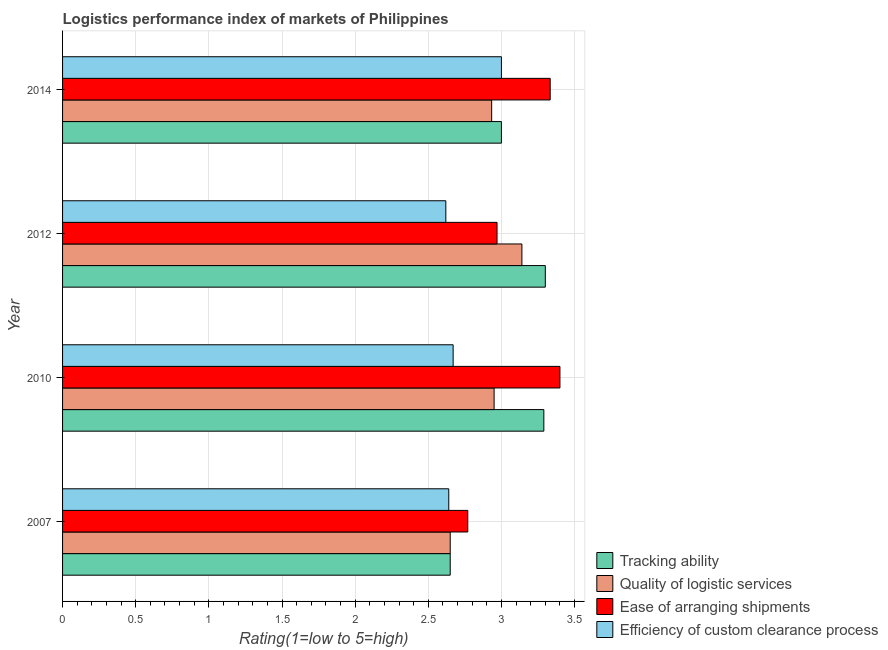How many different coloured bars are there?
Offer a terse response. 4. How many bars are there on the 3rd tick from the top?
Give a very brief answer. 4. What is the label of the 4th group of bars from the top?
Make the answer very short. 2007. What is the lpi rating of quality of logistic services in 2012?
Provide a short and direct response. 3.14. Across all years, what is the maximum lpi rating of efficiency of custom clearance process?
Give a very brief answer. 3. Across all years, what is the minimum lpi rating of efficiency of custom clearance process?
Make the answer very short. 2.62. In which year was the lpi rating of ease of arranging shipments maximum?
Keep it short and to the point. 2010. What is the total lpi rating of ease of arranging shipments in the graph?
Provide a succinct answer. 12.47. What is the difference between the lpi rating of tracking ability in 2010 and that in 2014?
Your answer should be very brief. 0.29. What is the difference between the lpi rating of tracking ability in 2012 and the lpi rating of efficiency of custom clearance process in 2007?
Your answer should be very brief. 0.66. What is the average lpi rating of quality of logistic services per year?
Make the answer very short. 2.92. In the year 2007, what is the difference between the lpi rating of quality of logistic services and lpi rating of ease of arranging shipments?
Offer a very short reply. -0.12. In how many years, is the lpi rating of tracking ability greater than 2 ?
Your answer should be compact. 4. What is the ratio of the lpi rating of tracking ability in 2007 to that in 2010?
Your answer should be very brief. 0.81. Is the lpi rating of efficiency of custom clearance process in 2007 less than that in 2014?
Offer a very short reply. Yes. Is the difference between the lpi rating of tracking ability in 2010 and 2012 greater than the difference between the lpi rating of efficiency of custom clearance process in 2010 and 2012?
Provide a succinct answer. No. What is the difference between the highest and the second highest lpi rating of quality of logistic services?
Provide a succinct answer. 0.19. What is the difference between the highest and the lowest lpi rating of quality of logistic services?
Make the answer very short. 0.49. In how many years, is the lpi rating of ease of arranging shipments greater than the average lpi rating of ease of arranging shipments taken over all years?
Ensure brevity in your answer.  2. Is the sum of the lpi rating of tracking ability in 2007 and 2014 greater than the maximum lpi rating of quality of logistic services across all years?
Make the answer very short. Yes. What does the 1st bar from the top in 2010 represents?
Provide a succinct answer. Efficiency of custom clearance process. What does the 4th bar from the bottom in 2007 represents?
Your answer should be very brief. Efficiency of custom clearance process. How many bars are there?
Your response must be concise. 16. What is the difference between two consecutive major ticks on the X-axis?
Ensure brevity in your answer.  0.5. Are the values on the major ticks of X-axis written in scientific E-notation?
Your answer should be compact. No. Does the graph contain any zero values?
Your answer should be compact. No. How are the legend labels stacked?
Give a very brief answer. Vertical. What is the title of the graph?
Your answer should be very brief. Logistics performance index of markets of Philippines. Does "Industry" appear as one of the legend labels in the graph?
Make the answer very short. No. What is the label or title of the X-axis?
Provide a succinct answer. Rating(1=low to 5=high). What is the label or title of the Y-axis?
Your response must be concise. Year. What is the Rating(1=low to 5=high) of Tracking ability in 2007?
Ensure brevity in your answer.  2.65. What is the Rating(1=low to 5=high) of Quality of logistic services in 2007?
Provide a succinct answer. 2.65. What is the Rating(1=low to 5=high) of Ease of arranging shipments in 2007?
Offer a very short reply. 2.77. What is the Rating(1=low to 5=high) in Efficiency of custom clearance process in 2007?
Your answer should be very brief. 2.64. What is the Rating(1=low to 5=high) in Tracking ability in 2010?
Your response must be concise. 3.29. What is the Rating(1=low to 5=high) in Quality of logistic services in 2010?
Offer a very short reply. 2.95. What is the Rating(1=low to 5=high) in Ease of arranging shipments in 2010?
Your answer should be compact. 3.4. What is the Rating(1=low to 5=high) of Efficiency of custom clearance process in 2010?
Ensure brevity in your answer.  2.67. What is the Rating(1=low to 5=high) of Tracking ability in 2012?
Make the answer very short. 3.3. What is the Rating(1=low to 5=high) in Quality of logistic services in 2012?
Make the answer very short. 3.14. What is the Rating(1=low to 5=high) in Ease of arranging shipments in 2012?
Your answer should be very brief. 2.97. What is the Rating(1=low to 5=high) in Efficiency of custom clearance process in 2012?
Keep it short and to the point. 2.62. What is the Rating(1=low to 5=high) of Tracking ability in 2014?
Your response must be concise. 3. What is the Rating(1=low to 5=high) in Quality of logistic services in 2014?
Your answer should be very brief. 2.93. What is the Rating(1=low to 5=high) in Ease of arranging shipments in 2014?
Your answer should be compact. 3.33. Across all years, what is the maximum Rating(1=low to 5=high) of Quality of logistic services?
Your response must be concise. 3.14. Across all years, what is the maximum Rating(1=low to 5=high) in Ease of arranging shipments?
Give a very brief answer. 3.4. Across all years, what is the minimum Rating(1=low to 5=high) in Tracking ability?
Your answer should be very brief. 2.65. Across all years, what is the minimum Rating(1=low to 5=high) in Quality of logistic services?
Make the answer very short. 2.65. Across all years, what is the minimum Rating(1=low to 5=high) in Ease of arranging shipments?
Your response must be concise. 2.77. Across all years, what is the minimum Rating(1=low to 5=high) in Efficiency of custom clearance process?
Ensure brevity in your answer.  2.62. What is the total Rating(1=low to 5=high) of Tracking ability in the graph?
Your answer should be compact. 12.24. What is the total Rating(1=low to 5=high) of Quality of logistic services in the graph?
Provide a short and direct response. 11.67. What is the total Rating(1=low to 5=high) in Ease of arranging shipments in the graph?
Provide a short and direct response. 12.47. What is the total Rating(1=low to 5=high) in Efficiency of custom clearance process in the graph?
Keep it short and to the point. 10.93. What is the difference between the Rating(1=low to 5=high) in Tracking ability in 2007 and that in 2010?
Ensure brevity in your answer.  -0.64. What is the difference between the Rating(1=low to 5=high) in Ease of arranging shipments in 2007 and that in 2010?
Provide a short and direct response. -0.63. What is the difference between the Rating(1=low to 5=high) in Efficiency of custom clearance process in 2007 and that in 2010?
Make the answer very short. -0.03. What is the difference between the Rating(1=low to 5=high) of Tracking ability in 2007 and that in 2012?
Your answer should be compact. -0.65. What is the difference between the Rating(1=low to 5=high) in Quality of logistic services in 2007 and that in 2012?
Offer a very short reply. -0.49. What is the difference between the Rating(1=low to 5=high) of Ease of arranging shipments in 2007 and that in 2012?
Your answer should be very brief. -0.2. What is the difference between the Rating(1=low to 5=high) in Efficiency of custom clearance process in 2007 and that in 2012?
Your response must be concise. 0.02. What is the difference between the Rating(1=low to 5=high) of Tracking ability in 2007 and that in 2014?
Offer a very short reply. -0.35. What is the difference between the Rating(1=low to 5=high) of Quality of logistic services in 2007 and that in 2014?
Offer a terse response. -0.28. What is the difference between the Rating(1=low to 5=high) in Ease of arranging shipments in 2007 and that in 2014?
Your response must be concise. -0.56. What is the difference between the Rating(1=low to 5=high) in Efficiency of custom clearance process in 2007 and that in 2014?
Your answer should be compact. -0.36. What is the difference between the Rating(1=low to 5=high) in Tracking ability in 2010 and that in 2012?
Your response must be concise. -0.01. What is the difference between the Rating(1=low to 5=high) of Quality of logistic services in 2010 and that in 2012?
Provide a succinct answer. -0.19. What is the difference between the Rating(1=low to 5=high) in Ease of arranging shipments in 2010 and that in 2012?
Offer a very short reply. 0.43. What is the difference between the Rating(1=low to 5=high) of Efficiency of custom clearance process in 2010 and that in 2012?
Make the answer very short. 0.05. What is the difference between the Rating(1=low to 5=high) of Tracking ability in 2010 and that in 2014?
Make the answer very short. 0.29. What is the difference between the Rating(1=low to 5=high) in Quality of logistic services in 2010 and that in 2014?
Provide a succinct answer. 0.02. What is the difference between the Rating(1=low to 5=high) in Ease of arranging shipments in 2010 and that in 2014?
Provide a succinct answer. 0.07. What is the difference between the Rating(1=low to 5=high) of Efficiency of custom clearance process in 2010 and that in 2014?
Your response must be concise. -0.33. What is the difference between the Rating(1=low to 5=high) of Tracking ability in 2012 and that in 2014?
Provide a short and direct response. 0.3. What is the difference between the Rating(1=low to 5=high) in Quality of logistic services in 2012 and that in 2014?
Provide a short and direct response. 0.21. What is the difference between the Rating(1=low to 5=high) of Ease of arranging shipments in 2012 and that in 2014?
Keep it short and to the point. -0.36. What is the difference between the Rating(1=low to 5=high) in Efficiency of custom clearance process in 2012 and that in 2014?
Provide a short and direct response. -0.38. What is the difference between the Rating(1=low to 5=high) in Tracking ability in 2007 and the Rating(1=low to 5=high) in Quality of logistic services in 2010?
Provide a succinct answer. -0.3. What is the difference between the Rating(1=low to 5=high) in Tracking ability in 2007 and the Rating(1=low to 5=high) in Ease of arranging shipments in 2010?
Ensure brevity in your answer.  -0.75. What is the difference between the Rating(1=low to 5=high) of Tracking ability in 2007 and the Rating(1=low to 5=high) of Efficiency of custom clearance process in 2010?
Offer a terse response. -0.02. What is the difference between the Rating(1=low to 5=high) of Quality of logistic services in 2007 and the Rating(1=low to 5=high) of Ease of arranging shipments in 2010?
Provide a succinct answer. -0.75. What is the difference between the Rating(1=low to 5=high) of Quality of logistic services in 2007 and the Rating(1=low to 5=high) of Efficiency of custom clearance process in 2010?
Provide a succinct answer. -0.02. What is the difference between the Rating(1=low to 5=high) in Tracking ability in 2007 and the Rating(1=low to 5=high) in Quality of logistic services in 2012?
Your answer should be very brief. -0.49. What is the difference between the Rating(1=low to 5=high) of Tracking ability in 2007 and the Rating(1=low to 5=high) of Ease of arranging shipments in 2012?
Provide a short and direct response. -0.32. What is the difference between the Rating(1=low to 5=high) in Tracking ability in 2007 and the Rating(1=low to 5=high) in Efficiency of custom clearance process in 2012?
Your answer should be compact. 0.03. What is the difference between the Rating(1=low to 5=high) of Quality of logistic services in 2007 and the Rating(1=low to 5=high) of Ease of arranging shipments in 2012?
Give a very brief answer. -0.32. What is the difference between the Rating(1=low to 5=high) of Tracking ability in 2007 and the Rating(1=low to 5=high) of Quality of logistic services in 2014?
Offer a terse response. -0.28. What is the difference between the Rating(1=low to 5=high) in Tracking ability in 2007 and the Rating(1=low to 5=high) in Ease of arranging shipments in 2014?
Your answer should be very brief. -0.68. What is the difference between the Rating(1=low to 5=high) in Tracking ability in 2007 and the Rating(1=low to 5=high) in Efficiency of custom clearance process in 2014?
Make the answer very short. -0.35. What is the difference between the Rating(1=low to 5=high) in Quality of logistic services in 2007 and the Rating(1=low to 5=high) in Ease of arranging shipments in 2014?
Give a very brief answer. -0.68. What is the difference between the Rating(1=low to 5=high) in Quality of logistic services in 2007 and the Rating(1=low to 5=high) in Efficiency of custom clearance process in 2014?
Your answer should be compact. -0.35. What is the difference between the Rating(1=low to 5=high) in Ease of arranging shipments in 2007 and the Rating(1=low to 5=high) in Efficiency of custom clearance process in 2014?
Your answer should be compact. -0.23. What is the difference between the Rating(1=low to 5=high) in Tracking ability in 2010 and the Rating(1=low to 5=high) in Ease of arranging shipments in 2012?
Your response must be concise. 0.32. What is the difference between the Rating(1=low to 5=high) of Tracking ability in 2010 and the Rating(1=low to 5=high) of Efficiency of custom clearance process in 2012?
Provide a short and direct response. 0.67. What is the difference between the Rating(1=low to 5=high) in Quality of logistic services in 2010 and the Rating(1=low to 5=high) in Ease of arranging shipments in 2012?
Provide a succinct answer. -0.02. What is the difference between the Rating(1=low to 5=high) in Quality of logistic services in 2010 and the Rating(1=low to 5=high) in Efficiency of custom clearance process in 2012?
Provide a succinct answer. 0.33. What is the difference between the Rating(1=low to 5=high) in Ease of arranging shipments in 2010 and the Rating(1=low to 5=high) in Efficiency of custom clearance process in 2012?
Offer a terse response. 0.78. What is the difference between the Rating(1=low to 5=high) of Tracking ability in 2010 and the Rating(1=low to 5=high) of Quality of logistic services in 2014?
Your response must be concise. 0.36. What is the difference between the Rating(1=low to 5=high) of Tracking ability in 2010 and the Rating(1=low to 5=high) of Ease of arranging shipments in 2014?
Keep it short and to the point. -0.04. What is the difference between the Rating(1=low to 5=high) of Tracking ability in 2010 and the Rating(1=low to 5=high) of Efficiency of custom clearance process in 2014?
Your answer should be very brief. 0.29. What is the difference between the Rating(1=low to 5=high) in Quality of logistic services in 2010 and the Rating(1=low to 5=high) in Ease of arranging shipments in 2014?
Give a very brief answer. -0.38. What is the difference between the Rating(1=low to 5=high) of Quality of logistic services in 2010 and the Rating(1=low to 5=high) of Efficiency of custom clearance process in 2014?
Offer a terse response. -0.05. What is the difference between the Rating(1=low to 5=high) in Ease of arranging shipments in 2010 and the Rating(1=low to 5=high) in Efficiency of custom clearance process in 2014?
Ensure brevity in your answer.  0.4. What is the difference between the Rating(1=low to 5=high) of Tracking ability in 2012 and the Rating(1=low to 5=high) of Quality of logistic services in 2014?
Provide a short and direct response. 0.37. What is the difference between the Rating(1=low to 5=high) of Tracking ability in 2012 and the Rating(1=low to 5=high) of Ease of arranging shipments in 2014?
Keep it short and to the point. -0.03. What is the difference between the Rating(1=low to 5=high) in Tracking ability in 2012 and the Rating(1=low to 5=high) in Efficiency of custom clearance process in 2014?
Offer a very short reply. 0.3. What is the difference between the Rating(1=low to 5=high) in Quality of logistic services in 2012 and the Rating(1=low to 5=high) in Ease of arranging shipments in 2014?
Offer a very short reply. -0.19. What is the difference between the Rating(1=low to 5=high) of Quality of logistic services in 2012 and the Rating(1=low to 5=high) of Efficiency of custom clearance process in 2014?
Provide a succinct answer. 0.14. What is the difference between the Rating(1=low to 5=high) of Ease of arranging shipments in 2012 and the Rating(1=low to 5=high) of Efficiency of custom clearance process in 2014?
Your response must be concise. -0.03. What is the average Rating(1=low to 5=high) of Tracking ability per year?
Provide a succinct answer. 3.06. What is the average Rating(1=low to 5=high) of Quality of logistic services per year?
Your answer should be compact. 2.92. What is the average Rating(1=low to 5=high) of Ease of arranging shipments per year?
Offer a very short reply. 3.12. What is the average Rating(1=low to 5=high) of Efficiency of custom clearance process per year?
Ensure brevity in your answer.  2.73. In the year 2007, what is the difference between the Rating(1=low to 5=high) of Tracking ability and Rating(1=low to 5=high) of Quality of logistic services?
Keep it short and to the point. 0. In the year 2007, what is the difference between the Rating(1=low to 5=high) of Tracking ability and Rating(1=low to 5=high) of Ease of arranging shipments?
Your answer should be compact. -0.12. In the year 2007, what is the difference between the Rating(1=low to 5=high) of Quality of logistic services and Rating(1=low to 5=high) of Ease of arranging shipments?
Provide a short and direct response. -0.12. In the year 2007, what is the difference between the Rating(1=low to 5=high) of Ease of arranging shipments and Rating(1=low to 5=high) of Efficiency of custom clearance process?
Offer a terse response. 0.13. In the year 2010, what is the difference between the Rating(1=low to 5=high) of Tracking ability and Rating(1=low to 5=high) of Quality of logistic services?
Keep it short and to the point. 0.34. In the year 2010, what is the difference between the Rating(1=low to 5=high) in Tracking ability and Rating(1=low to 5=high) in Ease of arranging shipments?
Offer a very short reply. -0.11. In the year 2010, what is the difference between the Rating(1=low to 5=high) in Tracking ability and Rating(1=low to 5=high) in Efficiency of custom clearance process?
Your answer should be compact. 0.62. In the year 2010, what is the difference between the Rating(1=low to 5=high) in Quality of logistic services and Rating(1=low to 5=high) in Ease of arranging shipments?
Your response must be concise. -0.45. In the year 2010, what is the difference between the Rating(1=low to 5=high) in Quality of logistic services and Rating(1=low to 5=high) in Efficiency of custom clearance process?
Make the answer very short. 0.28. In the year 2010, what is the difference between the Rating(1=low to 5=high) in Ease of arranging shipments and Rating(1=low to 5=high) in Efficiency of custom clearance process?
Provide a short and direct response. 0.73. In the year 2012, what is the difference between the Rating(1=low to 5=high) in Tracking ability and Rating(1=low to 5=high) in Quality of logistic services?
Your answer should be compact. 0.16. In the year 2012, what is the difference between the Rating(1=low to 5=high) of Tracking ability and Rating(1=low to 5=high) of Ease of arranging shipments?
Your answer should be compact. 0.33. In the year 2012, what is the difference between the Rating(1=low to 5=high) of Tracking ability and Rating(1=low to 5=high) of Efficiency of custom clearance process?
Provide a succinct answer. 0.68. In the year 2012, what is the difference between the Rating(1=low to 5=high) in Quality of logistic services and Rating(1=low to 5=high) in Ease of arranging shipments?
Provide a short and direct response. 0.17. In the year 2012, what is the difference between the Rating(1=low to 5=high) of Quality of logistic services and Rating(1=low to 5=high) of Efficiency of custom clearance process?
Give a very brief answer. 0.52. In the year 2014, what is the difference between the Rating(1=low to 5=high) in Tracking ability and Rating(1=low to 5=high) in Quality of logistic services?
Keep it short and to the point. 0.07. In the year 2014, what is the difference between the Rating(1=low to 5=high) in Quality of logistic services and Rating(1=low to 5=high) in Efficiency of custom clearance process?
Make the answer very short. -0.07. What is the ratio of the Rating(1=low to 5=high) of Tracking ability in 2007 to that in 2010?
Provide a succinct answer. 0.81. What is the ratio of the Rating(1=low to 5=high) of Quality of logistic services in 2007 to that in 2010?
Make the answer very short. 0.9. What is the ratio of the Rating(1=low to 5=high) in Ease of arranging shipments in 2007 to that in 2010?
Give a very brief answer. 0.81. What is the ratio of the Rating(1=low to 5=high) of Tracking ability in 2007 to that in 2012?
Offer a terse response. 0.8. What is the ratio of the Rating(1=low to 5=high) in Quality of logistic services in 2007 to that in 2012?
Offer a very short reply. 0.84. What is the ratio of the Rating(1=low to 5=high) of Ease of arranging shipments in 2007 to that in 2012?
Your answer should be compact. 0.93. What is the ratio of the Rating(1=low to 5=high) of Efficiency of custom clearance process in 2007 to that in 2012?
Give a very brief answer. 1.01. What is the ratio of the Rating(1=low to 5=high) in Tracking ability in 2007 to that in 2014?
Your response must be concise. 0.88. What is the ratio of the Rating(1=low to 5=high) of Quality of logistic services in 2007 to that in 2014?
Provide a succinct answer. 0.9. What is the ratio of the Rating(1=low to 5=high) of Ease of arranging shipments in 2007 to that in 2014?
Give a very brief answer. 0.83. What is the ratio of the Rating(1=low to 5=high) of Efficiency of custom clearance process in 2007 to that in 2014?
Give a very brief answer. 0.88. What is the ratio of the Rating(1=low to 5=high) of Quality of logistic services in 2010 to that in 2012?
Keep it short and to the point. 0.94. What is the ratio of the Rating(1=low to 5=high) of Ease of arranging shipments in 2010 to that in 2012?
Offer a very short reply. 1.14. What is the ratio of the Rating(1=low to 5=high) of Efficiency of custom clearance process in 2010 to that in 2012?
Offer a very short reply. 1.02. What is the ratio of the Rating(1=low to 5=high) of Tracking ability in 2010 to that in 2014?
Your answer should be very brief. 1.1. What is the ratio of the Rating(1=low to 5=high) in Ease of arranging shipments in 2010 to that in 2014?
Your response must be concise. 1.02. What is the ratio of the Rating(1=low to 5=high) of Efficiency of custom clearance process in 2010 to that in 2014?
Give a very brief answer. 0.89. What is the ratio of the Rating(1=low to 5=high) of Quality of logistic services in 2012 to that in 2014?
Your response must be concise. 1.07. What is the ratio of the Rating(1=low to 5=high) in Ease of arranging shipments in 2012 to that in 2014?
Offer a terse response. 0.89. What is the ratio of the Rating(1=low to 5=high) of Efficiency of custom clearance process in 2012 to that in 2014?
Your answer should be very brief. 0.87. What is the difference between the highest and the second highest Rating(1=low to 5=high) of Quality of logistic services?
Provide a short and direct response. 0.19. What is the difference between the highest and the second highest Rating(1=low to 5=high) in Ease of arranging shipments?
Your response must be concise. 0.07. What is the difference between the highest and the second highest Rating(1=low to 5=high) of Efficiency of custom clearance process?
Offer a very short reply. 0.33. What is the difference between the highest and the lowest Rating(1=low to 5=high) of Tracking ability?
Offer a very short reply. 0.65. What is the difference between the highest and the lowest Rating(1=low to 5=high) of Quality of logistic services?
Make the answer very short. 0.49. What is the difference between the highest and the lowest Rating(1=low to 5=high) in Ease of arranging shipments?
Your answer should be compact. 0.63. What is the difference between the highest and the lowest Rating(1=low to 5=high) of Efficiency of custom clearance process?
Your response must be concise. 0.38. 